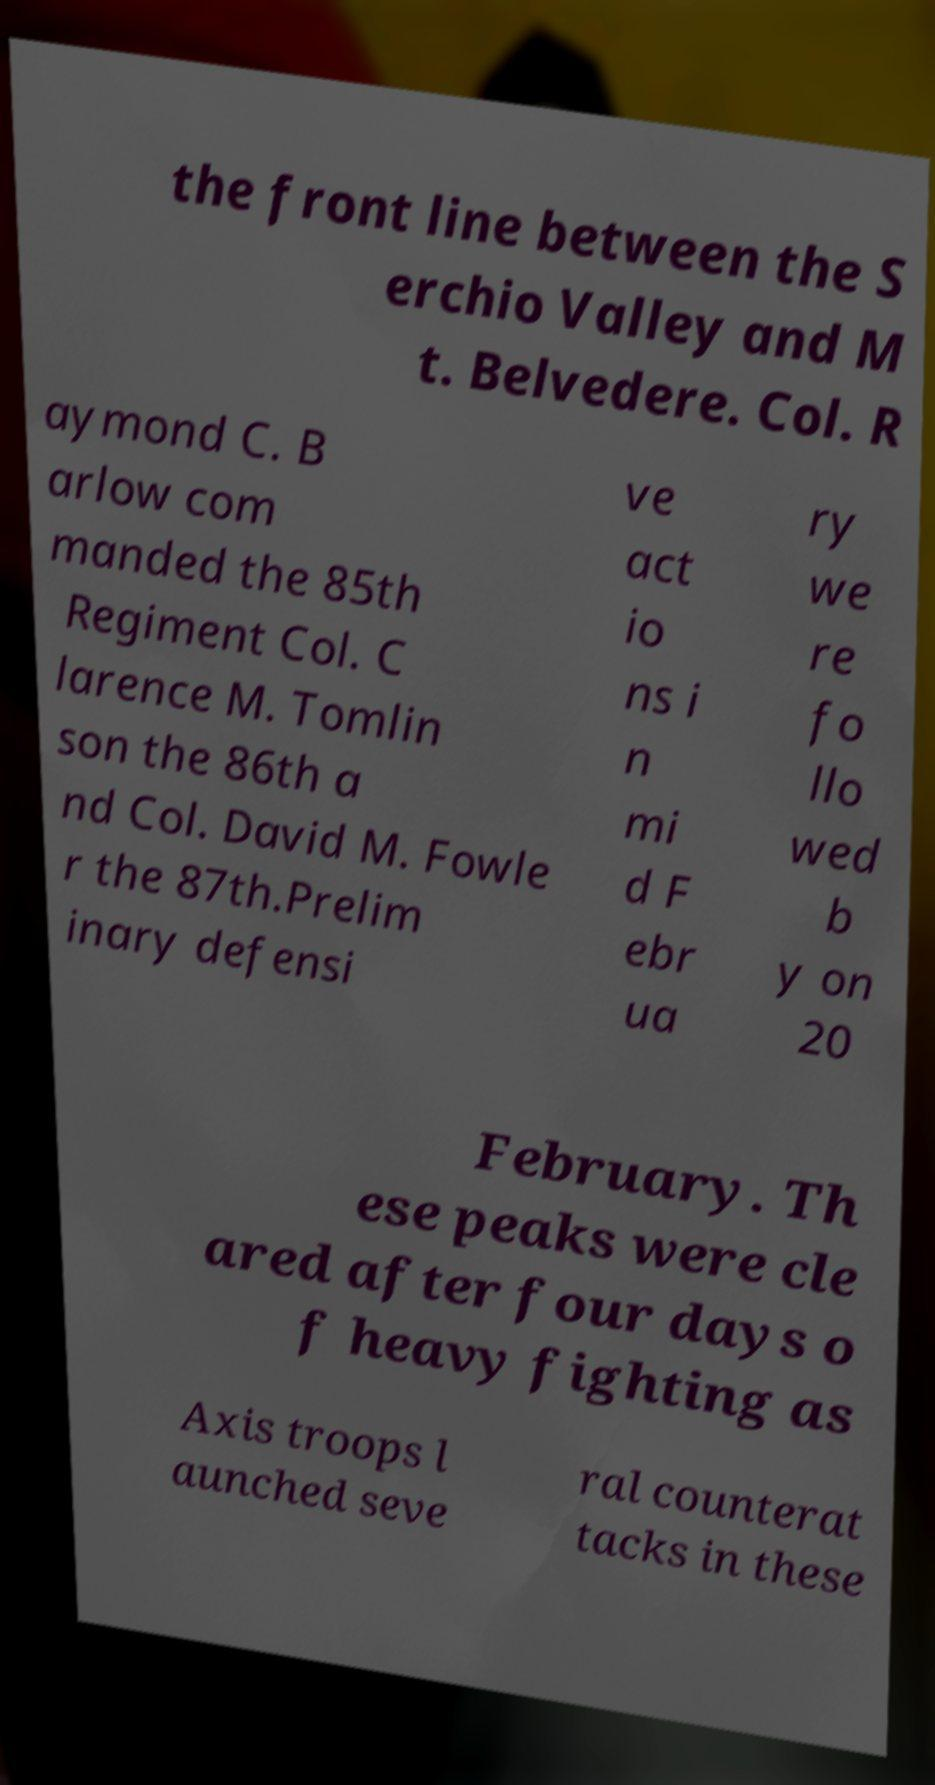I need the written content from this picture converted into text. Can you do that? the front line between the S erchio Valley and M t. Belvedere. Col. R aymond C. B arlow com manded the 85th Regiment Col. C larence M. Tomlin son the 86th a nd Col. David M. Fowle r the 87th.Prelim inary defensi ve act io ns i n mi d F ebr ua ry we re fo llo wed b y on 20 February. Th ese peaks were cle ared after four days o f heavy fighting as Axis troops l aunched seve ral counterat tacks in these 